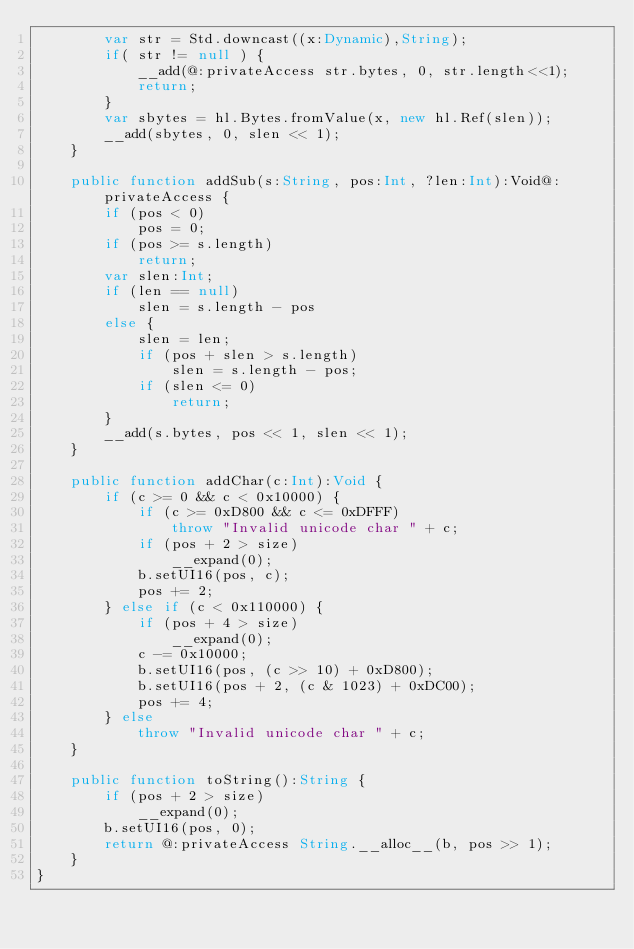<code> <loc_0><loc_0><loc_500><loc_500><_Haxe_>		var str = Std.downcast((x:Dynamic),String);
		if( str != null ) {
			__add(@:privateAccess str.bytes, 0, str.length<<1);
			return;
		}
		var sbytes = hl.Bytes.fromValue(x, new hl.Ref(slen));
		__add(sbytes, 0, slen << 1);
	}

	public function addSub(s:String, pos:Int, ?len:Int):Void@:privateAccess {
		if (pos < 0)
			pos = 0;
		if (pos >= s.length)
			return;
		var slen:Int;
		if (len == null)
			slen = s.length - pos
		else {
			slen = len;
			if (pos + slen > s.length)
				slen = s.length - pos;
			if (slen <= 0)
				return;
		}
		__add(s.bytes, pos << 1, slen << 1);
	}

	public function addChar(c:Int):Void {
		if (c >= 0 && c < 0x10000) {
			if (c >= 0xD800 && c <= 0xDFFF)
				throw "Invalid unicode char " + c;
			if (pos + 2 > size)
				__expand(0);
			b.setUI16(pos, c);
			pos += 2;
		} else if (c < 0x110000) {
			if (pos + 4 > size)
				__expand(0);
			c -= 0x10000;
			b.setUI16(pos, (c >> 10) + 0xD800);
			b.setUI16(pos + 2, (c & 1023) + 0xDC00);
			pos += 4;
		} else
			throw "Invalid unicode char " + c;
	}

	public function toString():String {
		if (pos + 2 > size)
			__expand(0);
		b.setUI16(pos, 0);
		return @:privateAccess String.__alloc__(b, pos >> 1);
	}
}
</code> 